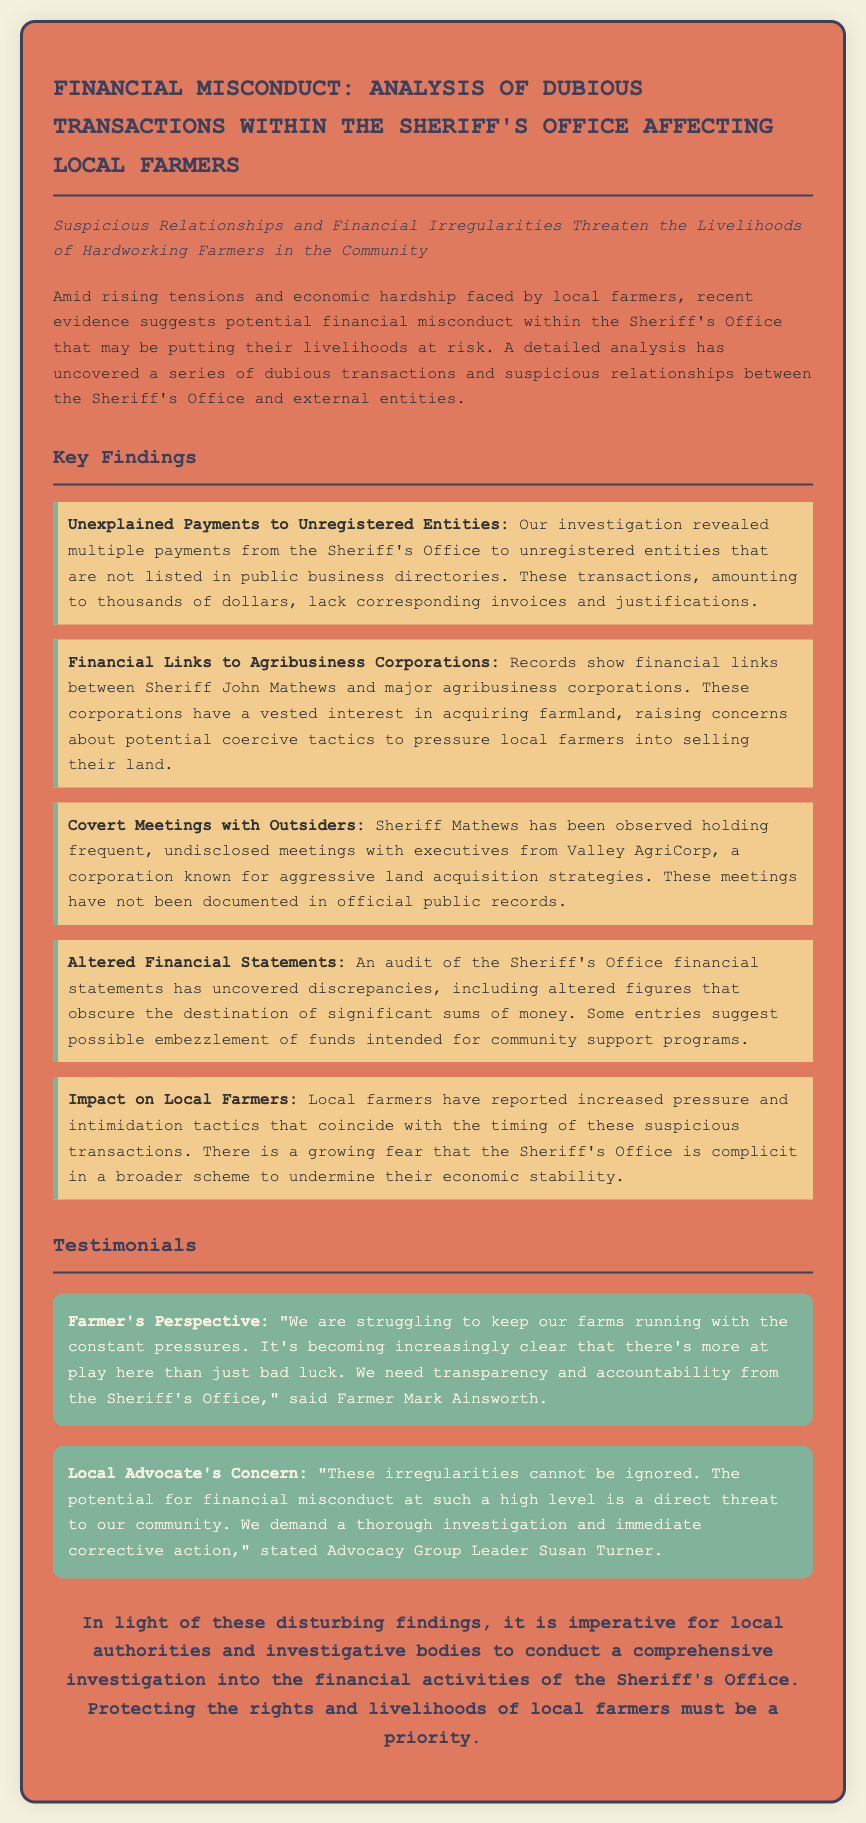What are the unexplained payments made to? The document states that there are multiple payments to unregistered entities that are not listed in public business directories.
Answer: Unregistered entities How much money is involved in the suspicious transactions? The document indicates that the transactions amount to thousands of dollars.
Answer: Thousands of dollars Who is the sheriff mentioned in the document? The sheriff referred to in the document is Sheriff John Mathews.
Answer: Sheriff John Mathews What corporation has been linked to covert meetings with the sheriff? The document mentions Valley AgriCorp as the corporation known for aggressive land acquisition strategies.
Answer: Valley AgriCorp What do local farmers report feeling due to the sheriff's office actions? Farmers have reported increased pressure and intimidation tactics due to the sheriff's office actions.
Answer: Increased pressure and intimidation What do the testimonials demand from the Sheriff's Office? The testimonials collectively demand transparency and accountability from the Sheriff's Office.
Answer: Transparency and accountability What is a possible outcome of the dubious transactions mentioned? The document suggests that the financial misconduct poses a threat to the economic stability of farmers.
Answer: Economic stability of farmers What was discovered during the audit of the Sheriff's Office financial statements? The audit uncovered discrepancies, including altered figures that obscure the destination of significant sums of money.
Answer: Discrepancies and altered figures What is stated as a priority in the conclusion of the document? The conclusion emphasizes that protecting the rights and livelihoods of local farmers must be a priority.
Answer: Rights and livelihoods of local farmers 